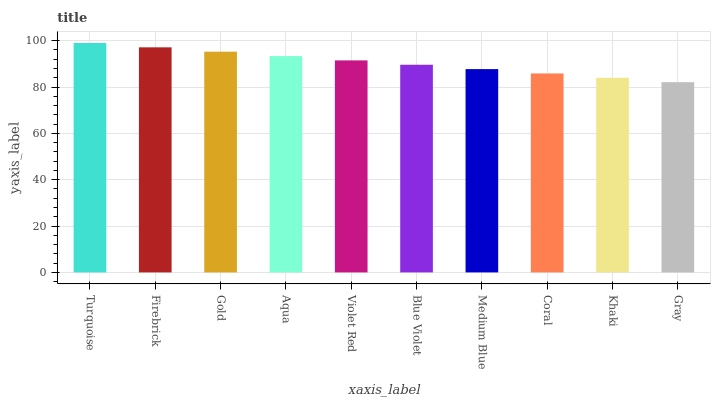Is Gray the minimum?
Answer yes or no. Yes. Is Turquoise the maximum?
Answer yes or no. Yes. Is Firebrick the minimum?
Answer yes or no. No. Is Firebrick the maximum?
Answer yes or no. No. Is Turquoise greater than Firebrick?
Answer yes or no. Yes. Is Firebrick less than Turquoise?
Answer yes or no. Yes. Is Firebrick greater than Turquoise?
Answer yes or no. No. Is Turquoise less than Firebrick?
Answer yes or no. No. Is Violet Red the high median?
Answer yes or no. Yes. Is Blue Violet the low median?
Answer yes or no. Yes. Is Firebrick the high median?
Answer yes or no. No. Is Aqua the low median?
Answer yes or no. No. 